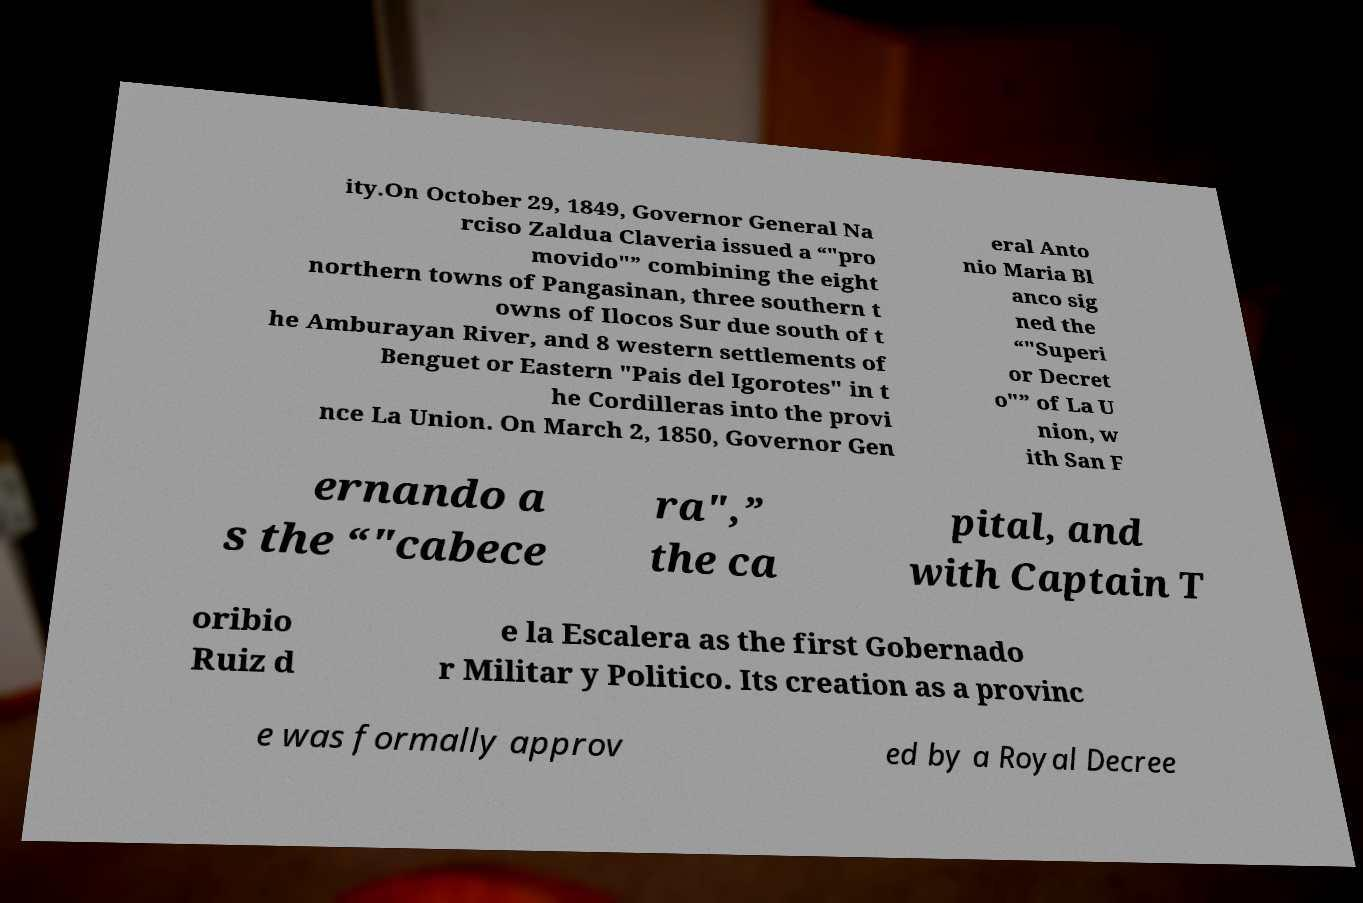I need the written content from this picture converted into text. Can you do that? ity.On October 29, 1849, Governor General Na rciso Zaldua Claveria issued a “"pro movido"” combining the eight northern towns of Pangasinan, three southern t owns of Ilocos Sur due south of t he Amburayan River, and 8 western settlements of Benguet or Eastern "Pais del Igorotes" in t he Cordilleras into the provi nce La Union. On March 2, 1850, Governor Gen eral Anto nio Maria Bl anco sig ned the “"Superi or Decret o"” of La U nion, w ith San F ernando a s the “"cabece ra",” the ca pital, and with Captain T oribio Ruiz d e la Escalera as the first Gobernado r Militar y Politico. Its creation as a provinc e was formally approv ed by a Royal Decree 